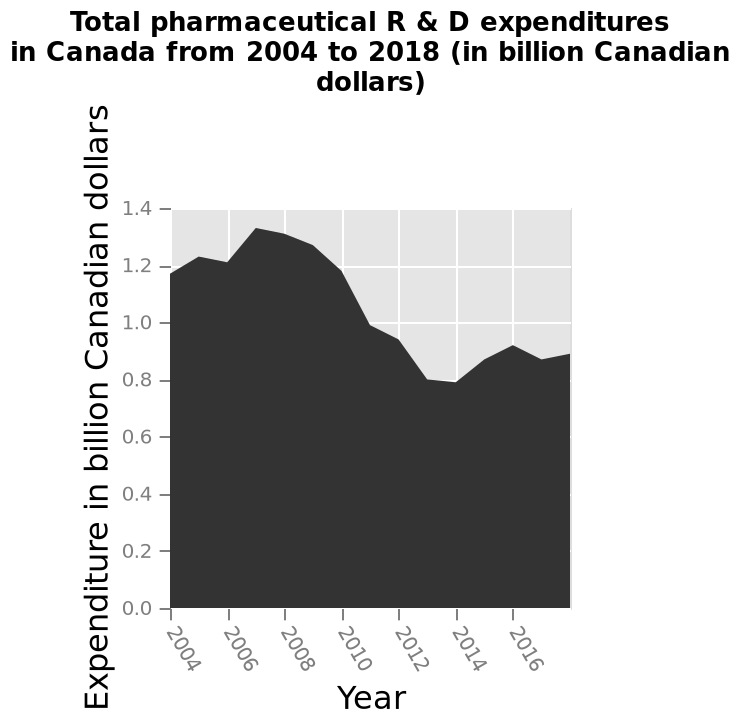<image>
please summary the statistics and relations of the chart Expenditure was highest around 2007 and then dropped in 2012 with a steady increase thereafter. 